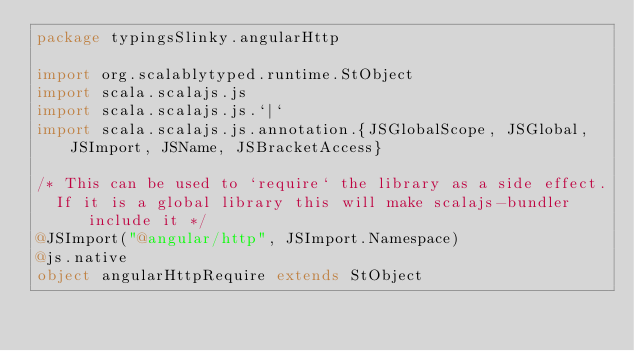Convert code to text. <code><loc_0><loc_0><loc_500><loc_500><_Scala_>package typingsSlinky.angularHttp

import org.scalablytyped.runtime.StObject
import scala.scalajs.js
import scala.scalajs.js.`|`
import scala.scalajs.js.annotation.{JSGlobalScope, JSGlobal, JSImport, JSName, JSBracketAccess}

/* This can be used to `require` the library as a side effect.
  If it is a global library this will make scalajs-bundler include it */
@JSImport("@angular/http", JSImport.Namespace)
@js.native
object angularHttpRequire extends StObject
</code> 